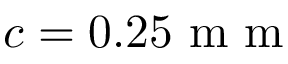Convert formula to latex. <formula><loc_0><loc_0><loc_500><loc_500>c = 0 . 2 5 m m</formula> 